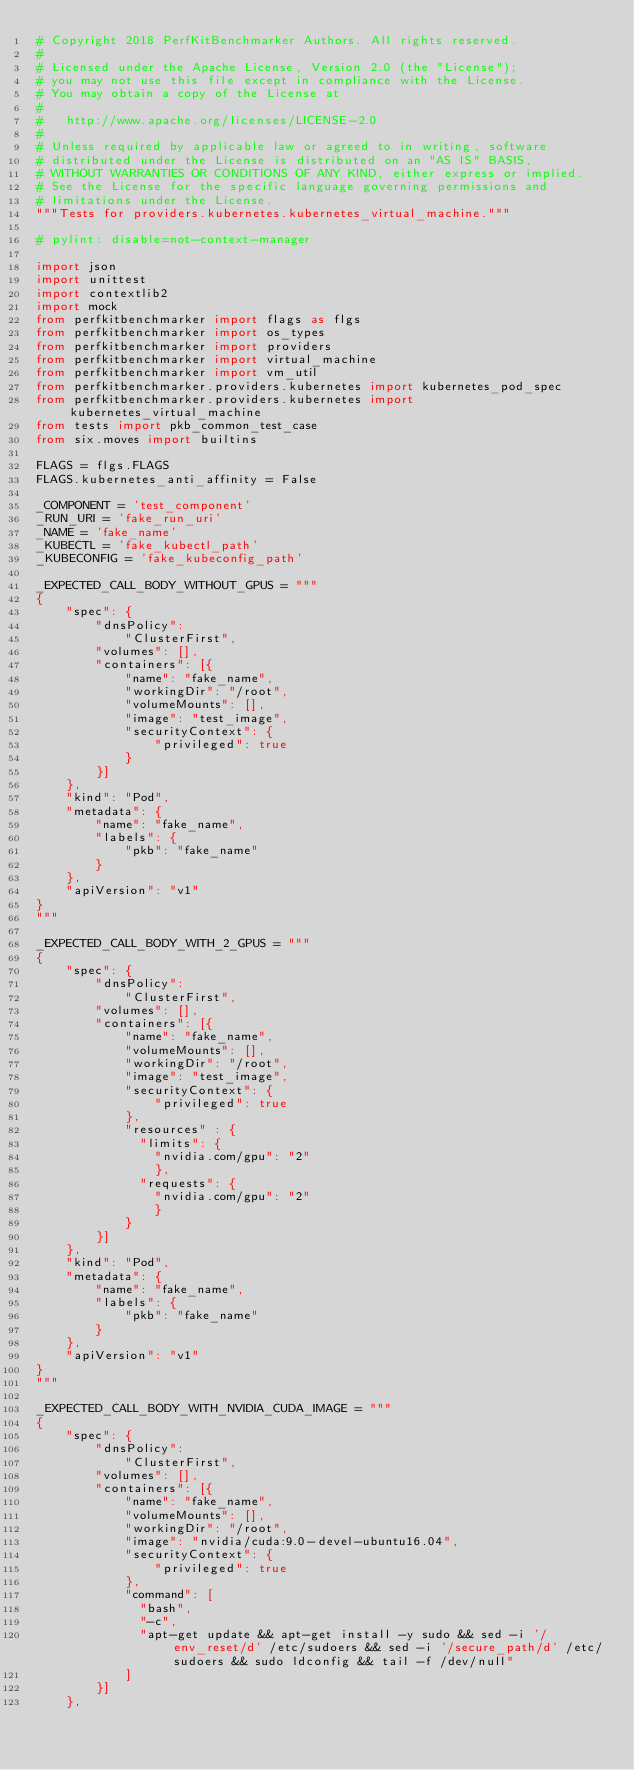Convert code to text. <code><loc_0><loc_0><loc_500><loc_500><_Python_># Copyright 2018 PerfKitBenchmarker Authors. All rights reserved.
#
# Licensed under the Apache License, Version 2.0 (the "License");
# you may not use this file except in compliance with the License.
# You may obtain a copy of the License at
#
#   http://www.apache.org/licenses/LICENSE-2.0
#
# Unless required by applicable law or agreed to in writing, software
# distributed under the License is distributed on an "AS IS" BASIS,
# WITHOUT WARRANTIES OR CONDITIONS OF ANY KIND, either express or implied.
# See the License for the specific language governing permissions and
# limitations under the License.
"""Tests for providers.kubernetes.kubernetes_virtual_machine."""

# pylint: disable=not-context-manager

import json
import unittest
import contextlib2
import mock
from perfkitbenchmarker import flags as flgs
from perfkitbenchmarker import os_types
from perfkitbenchmarker import providers
from perfkitbenchmarker import virtual_machine
from perfkitbenchmarker import vm_util
from perfkitbenchmarker.providers.kubernetes import kubernetes_pod_spec
from perfkitbenchmarker.providers.kubernetes import kubernetes_virtual_machine
from tests import pkb_common_test_case
from six.moves import builtins

FLAGS = flgs.FLAGS
FLAGS.kubernetes_anti_affinity = False

_COMPONENT = 'test_component'
_RUN_URI = 'fake_run_uri'
_NAME = 'fake_name'
_KUBECTL = 'fake_kubectl_path'
_KUBECONFIG = 'fake_kubeconfig_path'

_EXPECTED_CALL_BODY_WITHOUT_GPUS = """
{
    "spec": {
        "dnsPolicy":
            "ClusterFirst",
        "volumes": [],
        "containers": [{
            "name": "fake_name",
            "workingDir": "/root",
            "volumeMounts": [],
            "image": "test_image",
            "securityContext": {
                "privileged": true
            }
        }]
    },
    "kind": "Pod",
    "metadata": {
        "name": "fake_name",
        "labels": {
            "pkb": "fake_name"
        }
    },
    "apiVersion": "v1"
}
"""

_EXPECTED_CALL_BODY_WITH_2_GPUS = """
{
    "spec": {
        "dnsPolicy":
            "ClusterFirst",
        "volumes": [],
        "containers": [{
            "name": "fake_name",
            "volumeMounts": [],
            "workingDir": "/root",
            "image": "test_image",
            "securityContext": {
                "privileged": true
            },
            "resources" : {
              "limits": {
                "nvidia.com/gpu": "2"
                },
              "requests": {
                "nvidia.com/gpu": "2"
                }
            }
        }]
    },
    "kind": "Pod",
    "metadata": {
        "name": "fake_name",
        "labels": {
            "pkb": "fake_name"
        }
    },
    "apiVersion": "v1"
}
"""

_EXPECTED_CALL_BODY_WITH_NVIDIA_CUDA_IMAGE = """
{
    "spec": {
        "dnsPolicy":
            "ClusterFirst",
        "volumes": [],
        "containers": [{
            "name": "fake_name",
            "volumeMounts": [],
            "workingDir": "/root",
            "image": "nvidia/cuda:9.0-devel-ubuntu16.04",
            "securityContext": {
                "privileged": true
            },
            "command": [
              "bash",
              "-c",
              "apt-get update && apt-get install -y sudo && sed -i '/env_reset/d' /etc/sudoers && sed -i '/secure_path/d' /etc/sudoers && sudo ldconfig && tail -f /dev/null"
            ]
        }]
    },</code> 